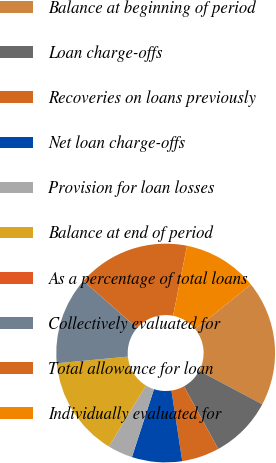Convert chart. <chart><loc_0><loc_0><loc_500><loc_500><pie_chart><fcel>Balance at beginning of period<fcel>Loan charge-offs<fcel>Recoveries on loans previously<fcel>Net loan charge-offs<fcel>Provision for loan losses<fcel>Balance at end of period<fcel>As a percentage of total loans<fcel>Collectively evaluated for<fcel>Total allowance for loan<fcel>Individually evaluated for<nl><fcel>18.52%<fcel>9.26%<fcel>5.56%<fcel>7.41%<fcel>3.7%<fcel>14.81%<fcel>0.0%<fcel>12.96%<fcel>16.67%<fcel>11.11%<nl></chart> 